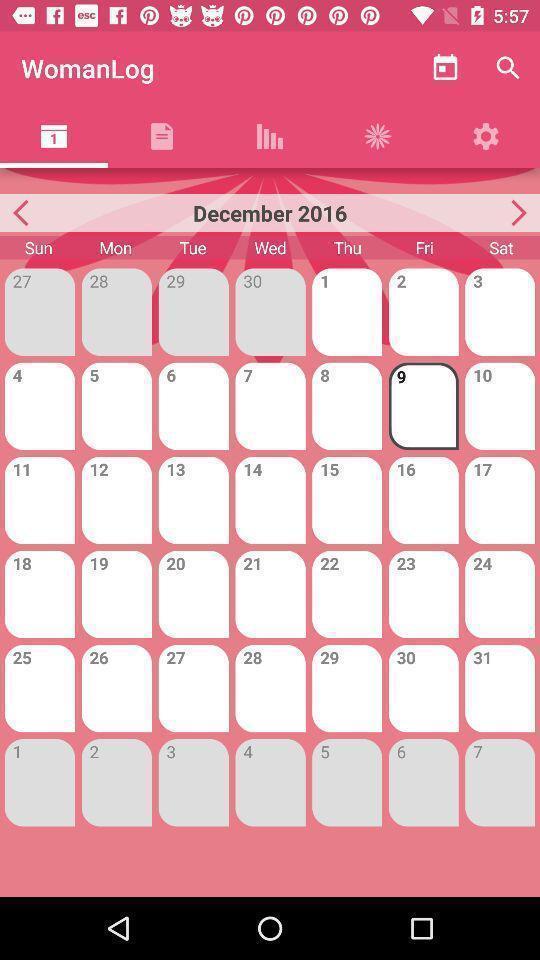Explain what's happening in this screen capture. Screen showing calendar with selected date. 